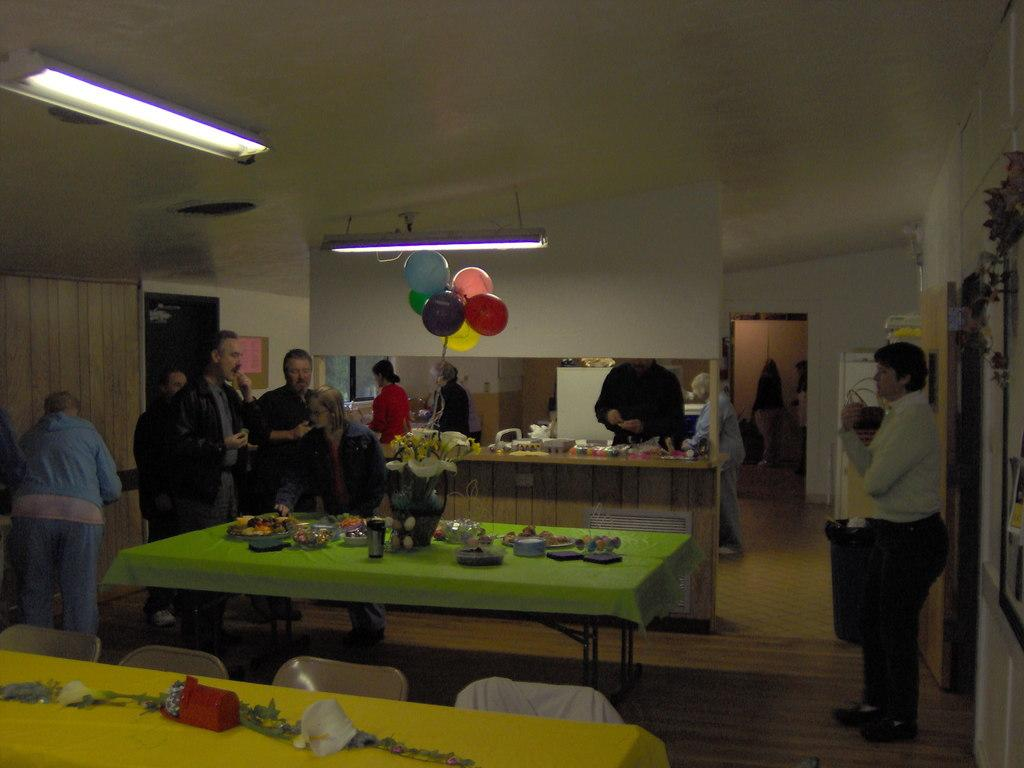How many people are in the image? There is a group of people in the image, but the exact number is not specified. What are the people in the image doing? The people are standing in the image. What is present in the image besides the group of people? There is a table in the image. What can be found on the table in the image? Food items are arranged on the table. What type of butter is being used to pin the fork to the table in the image? There is no butter, pin, or fork present in the image. 